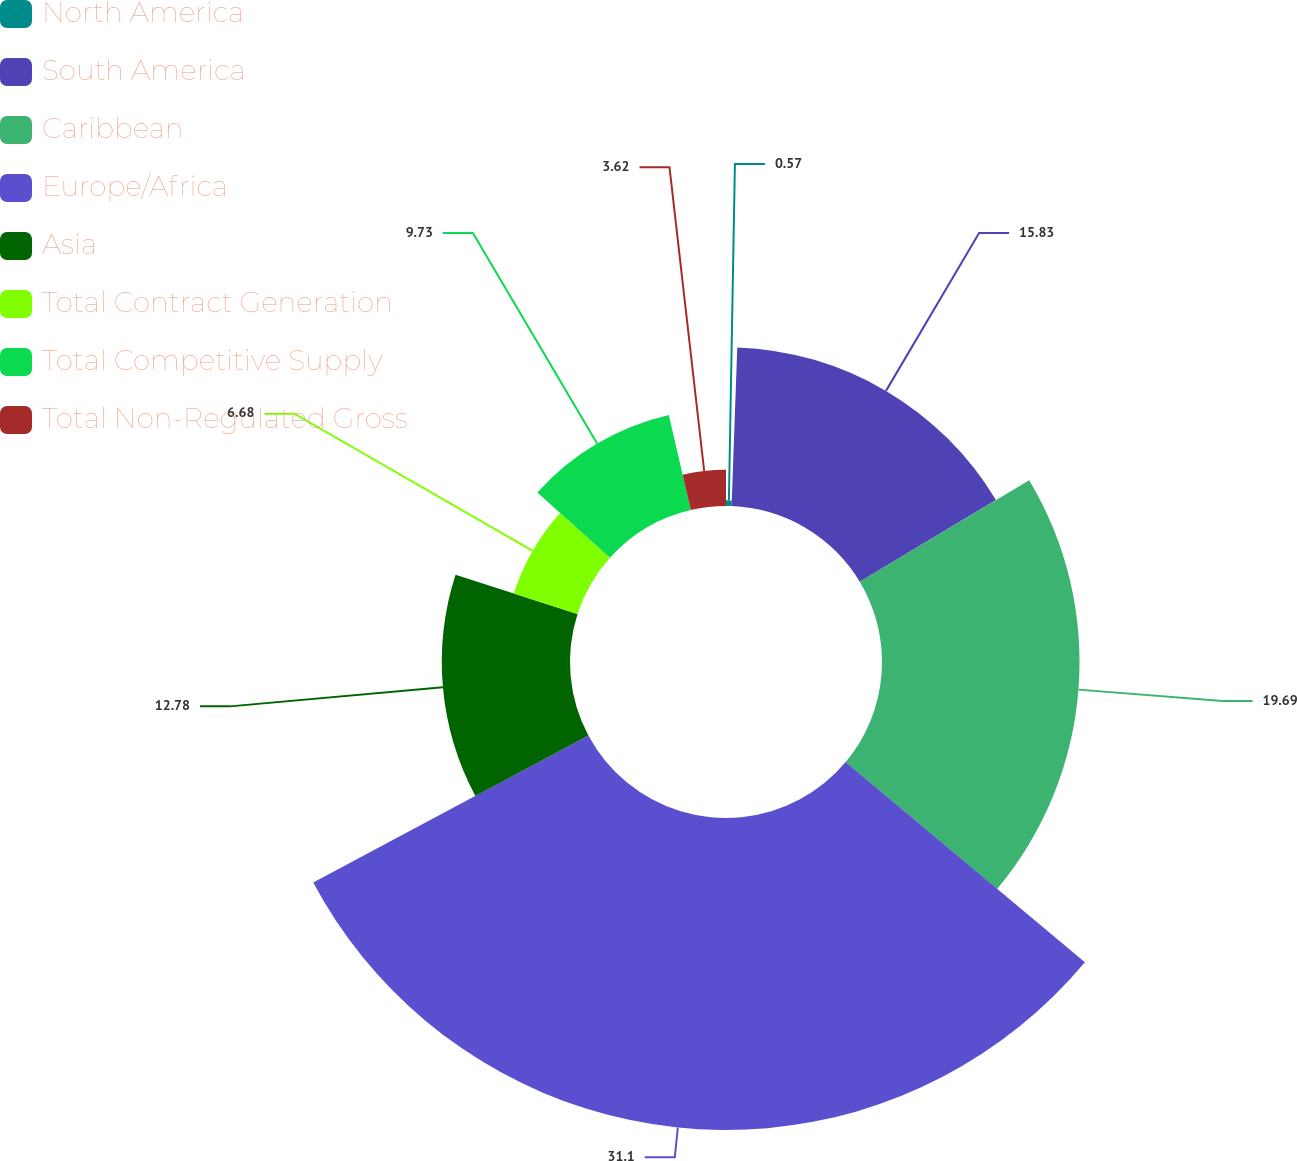Convert chart. <chart><loc_0><loc_0><loc_500><loc_500><pie_chart><fcel>North America<fcel>South America<fcel>Caribbean<fcel>Europe/Africa<fcel>Asia<fcel>Total Contract Generation<fcel>Total Competitive Supply<fcel>Total Non-Regulated Gross<nl><fcel>0.57%<fcel>15.83%<fcel>19.69%<fcel>31.1%<fcel>12.78%<fcel>6.68%<fcel>9.73%<fcel>3.62%<nl></chart> 